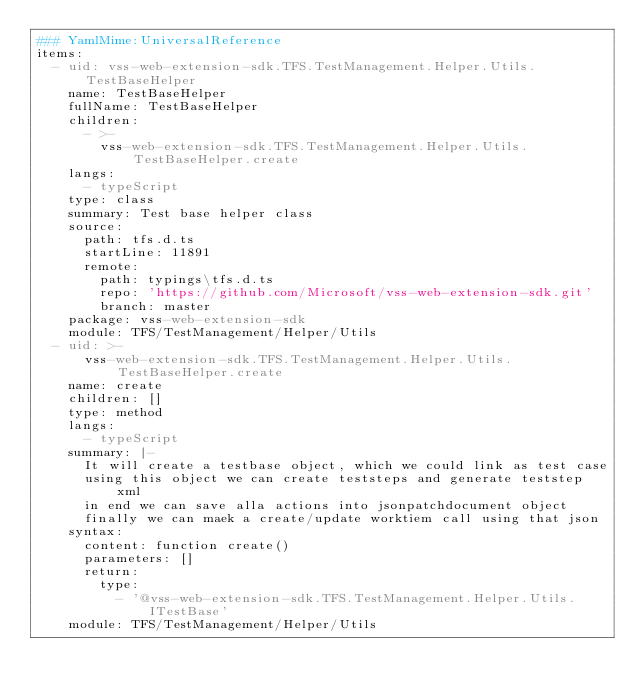Convert code to text. <code><loc_0><loc_0><loc_500><loc_500><_YAML_>### YamlMime:UniversalReference
items:
  - uid: vss-web-extension-sdk.TFS.TestManagement.Helper.Utils.TestBaseHelper
    name: TestBaseHelper
    fullName: TestBaseHelper
    children:
      - >-
        vss-web-extension-sdk.TFS.TestManagement.Helper.Utils.TestBaseHelper.create
    langs:
      - typeScript
    type: class
    summary: Test base helper class
    source:
      path: tfs.d.ts
      startLine: 11891
      remote:
        path: typings\tfs.d.ts
        repo: 'https://github.com/Microsoft/vss-web-extension-sdk.git'
        branch: master
    package: vss-web-extension-sdk
    module: TFS/TestManagement/Helper/Utils
  - uid: >-
      vss-web-extension-sdk.TFS.TestManagement.Helper.Utils.TestBaseHelper.create
    name: create
    children: []
    type: method
    langs:
      - typeScript
    summary: |-
      It will create a testbase object, which we could link as test case
      using this object we can create teststeps and generate teststep xml
      in end we can save alla actions into jsonpatchdocument object
      finally we can maek a create/update worktiem call using that json
    syntax:
      content: function create()
      parameters: []
      return:
        type:
          - '@vss-web-extension-sdk.TFS.TestManagement.Helper.Utils.ITestBase'
    module: TFS/TestManagement/Helper/Utils
</code> 